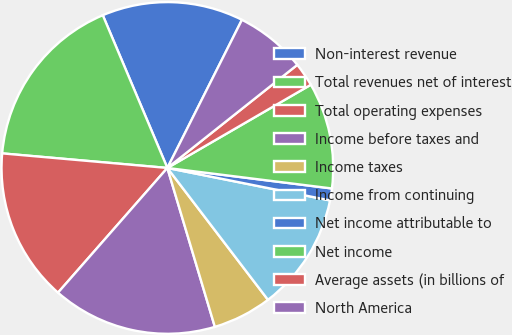<chart> <loc_0><loc_0><loc_500><loc_500><pie_chart><fcel>Non-interest revenue<fcel>Total revenues net of interest<fcel>Total operating expenses<fcel>Income before taxes and<fcel>Income taxes<fcel>Income from continuing<fcel>Net income attributable to<fcel>Net income<fcel>Average assets (in billions of<fcel>North America<nl><fcel>13.79%<fcel>17.23%<fcel>14.94%<fcel>16.08%<fcel>5.75%<fcel>11.49%<fcel>1.16%<fcel>10.34%<fcel>2.31%<fcel>6.9%<nl></chart> 